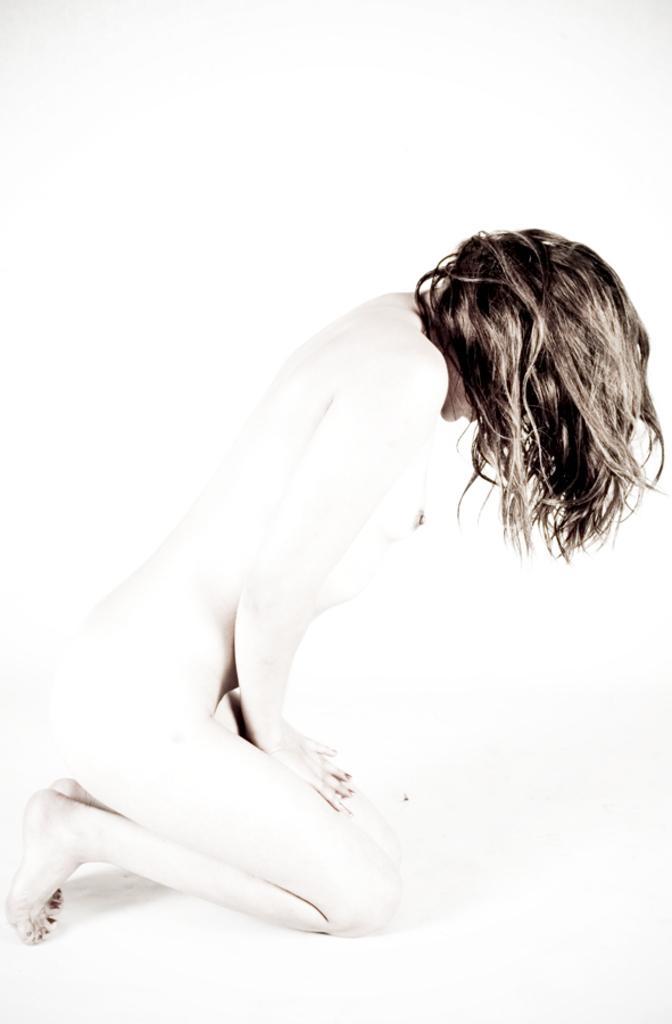How would you summarize this image in a sentence or two? A picture of a woman. Background it is in white color. 